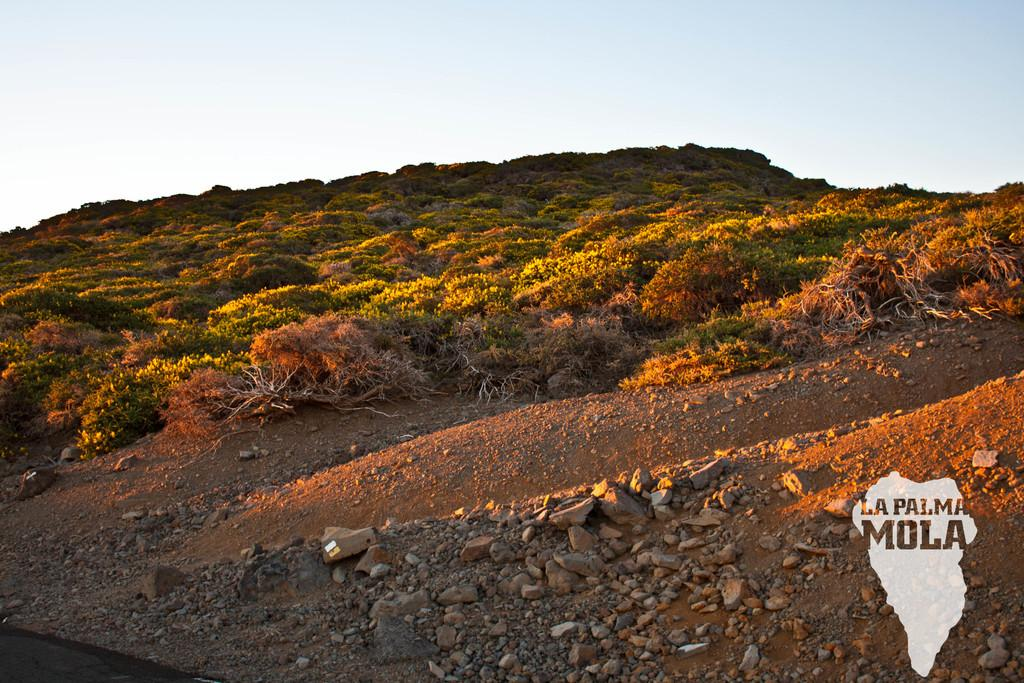What type of vegetation is present in the image? There are trees in the image. What other objects can be seen on the ground in the image? There are stones in the image. Where is the road located in the image? The road is in the bottom left of the image. What is visible at the top of the image? The sky is visible at the top of the image. What is written or depicted in the bottom right of the image? There is text in the bottom right of the image. How does the beetle interact with the text in the bottom right of the image? There is no beetle present in the image; it only contains trees, stones, a road, the sky, and text. 